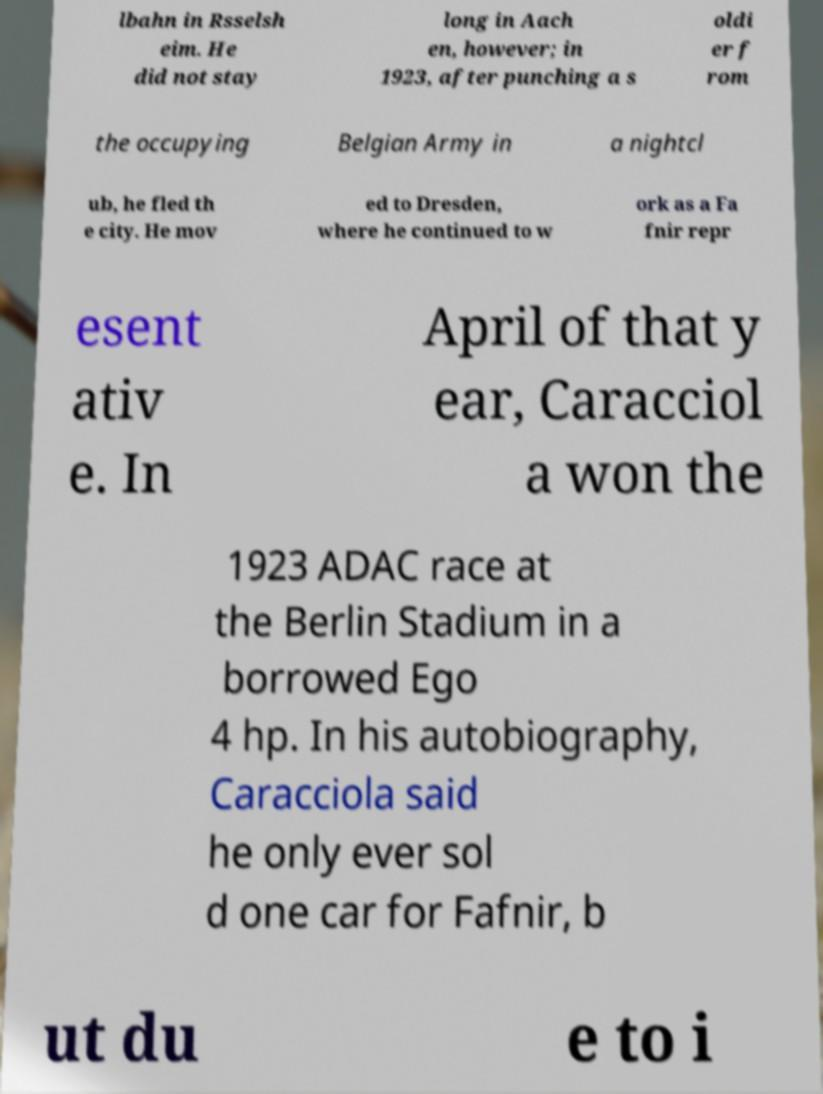Can you read and provide the text displayed in the image?This photo seems to have some interesting text. Can you extract and type it out for me? lbahn in Rsselsh eim. He did not stay long in Aach en, however; in 1923, after punching a s oldi er f rom the occupying Belgian Army in a nightcl ub, he fled th e city. He mov ed to Dresden, where he continued to w ork as a Fa fnir repr esent ativ e. In April of that y ear, Caracciol a won the 1923 ADAC race at the Berlin Stadium in a borrowed Ego 4 hp. In his autobiography, Caracciola said he only ever sol d one car for Fafnir, b ut du e to i 